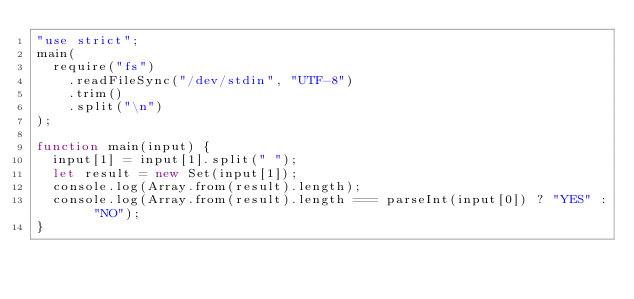Convert code to text. <code><loc_0><loc_0><loc_500><loc_500><_JavaScript_>"use strict";
main(
  require("fs")
    .readFileSync("/dev/stdin", "UTF-8")
    .trim()
    .split("\n")
);

function main(input) {
  input[1] = input[1].split(" ");
  let result = new Set(input[1]);
  console.log(Array.from(result).length);
  console.log(Array.from(result).length === parseInt(input[0]) ? "YES" : "NO");
}
</code> 